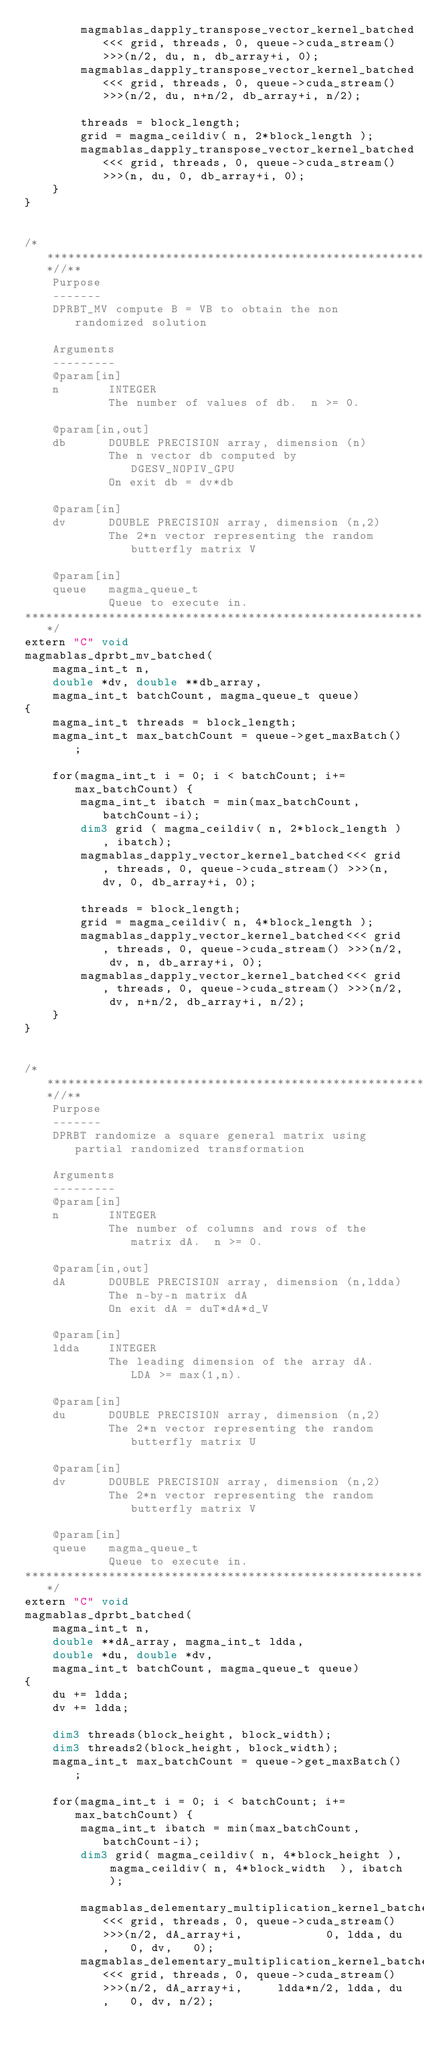Convert code to text. <code><loc_0><loc_0><loc_500><loc_500><_Cuda_>        magmablas_dapply_transpose_vector_kernel_batched<<< grid, threads, 0, queue->cuda_stream() >>>(n/2, du, n, db_array+i, 0);
        magmablas_dapply_transpose_vector_kernel_batched<<< grid, threads, 0, queue->cuda_stream() >>>(n/2, du, n+n/2, db_array+i, n/2);

        threads = block_length;
        grid = magma_ceildiv( n, 2*block_length );
        magmablas_dapply_transpose_vector_kernel_batched<<< grid, threads, 0, queue->cuda_stream() >>>(n, du, 0, db_array+i, 0);
    }
}


/***************************************************************************//**
    Purpose
    -------
    DPRBT_MV compute B = VB to obtain the non randomized solution

    Arguments
    ---------
    @param[in]
    n       INTEGER
            The number of values of db.  n >= 0.

    @param[in,out]
    db      DOUBLE PRECISION array, dimension (n)
            The n vector db computed by DGESV_NOPIV_GPU
            On exit db = dv*db

    @param[in]
    dv      DOUBLE PRECISION array, dimension (n,2)
            The 2*n vector representing the random butterfly matrix V

    @param[in]
    queue   magma_queue_t
            Queue to execute in.
*******************************************************************************/
extern "C" void
magmablas_dprbt_mv_batched(
    magma_int_t n,
    double *dv, double **db_array,
    magma_int_t batchCount, magma_queue_t queue)
{
    magma_int_t threads = block_length;
    magma_int_t max_batchCount = queue->get_maxBatch();

    for(magma_int_t i = 0; i < batchCount; i+=max_batchCount) {
        magma_int_t ibatch = min(max_batchCount, batchCount-i);
        dim3 grid ( magma_ceildiv( n, 2*block_length ), ibatch);
        magmablas_dapply_vector_kernel_batched<<< grid, threads, 0, queue->cuda_stream() >>>(n, dv, 0, db_array+i, 0);

        threads = block_length;
        grid = magma_ceildiv( n, 4*block_length );
        magmablas_dapply_vector_kernel_batched<<< grid, threads, 0, queue->cuda_stream() >>>(n/2, dv, n, db_array+i, 0);
        magmablas_dapply_vector_kernel_batched<<< grid, threads, 0, queue->cuda_stream() >>>(n/2, dv, n+n/2, db_array+i, n/2);
    }
}


/***************************************************************************//**
    Purpose
    -------
    DPRBT randomize a square general matrix using partial randomized transformation

    Arguments
    ---------
    @param[in]
    n       INTEGER
            The number of columns and rows of the matrix dA.  n >= 0.

    @param[in,out]
    dA      DOUBLE PRECISION array, dimension (n,ldda)
            The n-by-n matrix dA
            On exit dA = duT*dA*d_V

    @param[in]
    ldda    INTEGER
            The leading dimension of the array dA.  LDA >= max(1,n).

    @param[in]
    du      DOUBLE PRECISION array, dimension (n,2)
            The 2*n vector representing the random butterfly matrix U

    @param[in]
    dv      DOUBLE PRECISION array, dimension (n,2)
            The 2*n vector representing the random butterfly matrix V

    @param[in]
    queue   magma_queue_t
            Queue to execute in.
*******************************************************************************/
extern "C" void
magmablas_dprbt_batched(
    magma_int_t n,
    double **dA_array, magma_int_t ldda,
    double *du, double *dv,
    magma_int_t batchCount, magma_queue_t queue)
{
    du += ldda;
    dv += ldda;

    dim3 threads(block_height, block_width);
    dim3 threads2(block_height, block_width);
    magma_int_t max_batchCount = queue->get_maxBatch();

    for(magma_int_t i = 0; i < batchCount; i+=max_batchCount) {
        magma_int_t ibatch = min(max_batchCount, batchCount-i);
        dim3 grid( magma_ceildiv( n, 4*block_height ), magma_ceildiv( n, 4*block_width  ), ibatch );

        magmablas_delementary_multiplication_kernel_batched<<< grid, threads, 0, queue->cuda_stream() >>>(n/2, dA_array+i,            0, ldda, du,   0, dv,   0);
        magmablas_delementary_multiplication_kernel_batched<<< grid, threads, 0, queue->cuda_stream() >>>(n/2, dA_array+i,     ldda*n/2, ldda, du,   0, dv, n/2);</code> 